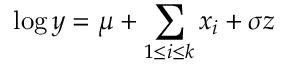Convert formula to latex. <formula><loc_0><loc_0><loc_500><loc_500>\log y = \mu + \sum _ { 1 \leq i \leq k } x _ { i } + \sigma z</formula> 